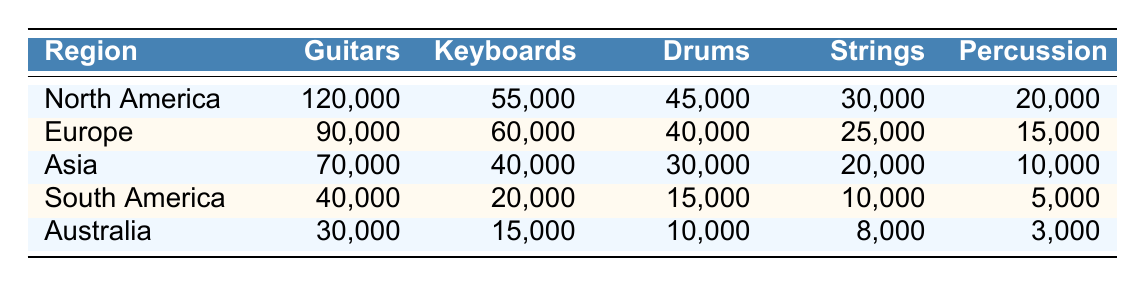What region has the highest sales of guitars? By looking at the values in the 'Guitars' column, I can see that North America has the highest value at 120,000 compared to Europe (90,000), Asia (70,000), South America (40,000), and Australia (30,000).
Answer: North America Which region sold 60,000 keyboards? The table shows that Europe has the value of 60,000 in the 'Keyboards' column. Other regions have lower values, confirming that Europe is the answer.
Answer: Europe What is the total sales of drums across all regions? I need to sum the values in the 'Drums' column: 45,000 (North America) + 40,000 (Europe) + 30,000 (Asia) + 15,000 (South America) + 10,000 (Australia) = 140,000.
Answer: 140,000 Is it true that Asia sold more drums than South America? Looking at the 'Drums' column, Asia has 30,000 while South America has 15,000, which confirms that Asia sold more drums.
Answer: Yes What is the average sales of percussion across all regions? To find the average, I first sum the values in the 'Percussion' column: 20,000 + 15,000 + 10,000 + 5,000 + 3,000 = 53,000. Then, I divide by the number of regions, which is 5, giving 53,000 / 5 = 10,600.
Answer: 10,600 Which musical instrument had the lowest total sales across all regions? I need to examine all the columns and compare the total values for each instrument: Guitars = 400,000, Keyboards = 225,000, Drums = 140,000, Strings = 113,000, and Percussion = 53,000. The lowest total sales are for Percussion.
Answer: Percussion How many more guitars were sold in North America than in Europe? From the 'Guitars' column, North America sold 120,000 guitars and Europe sold 90,000. Subtracting these gives 120,000 - 90,000 = 30,000 more guitars sold in North America.
Answer: 30,000 Did South America sell more strings than Australia? Checking the 'Strings' column, South America has 10,000 and Australia has 8,000, which means South America sold more strings than Australia.
Answer: Yes 